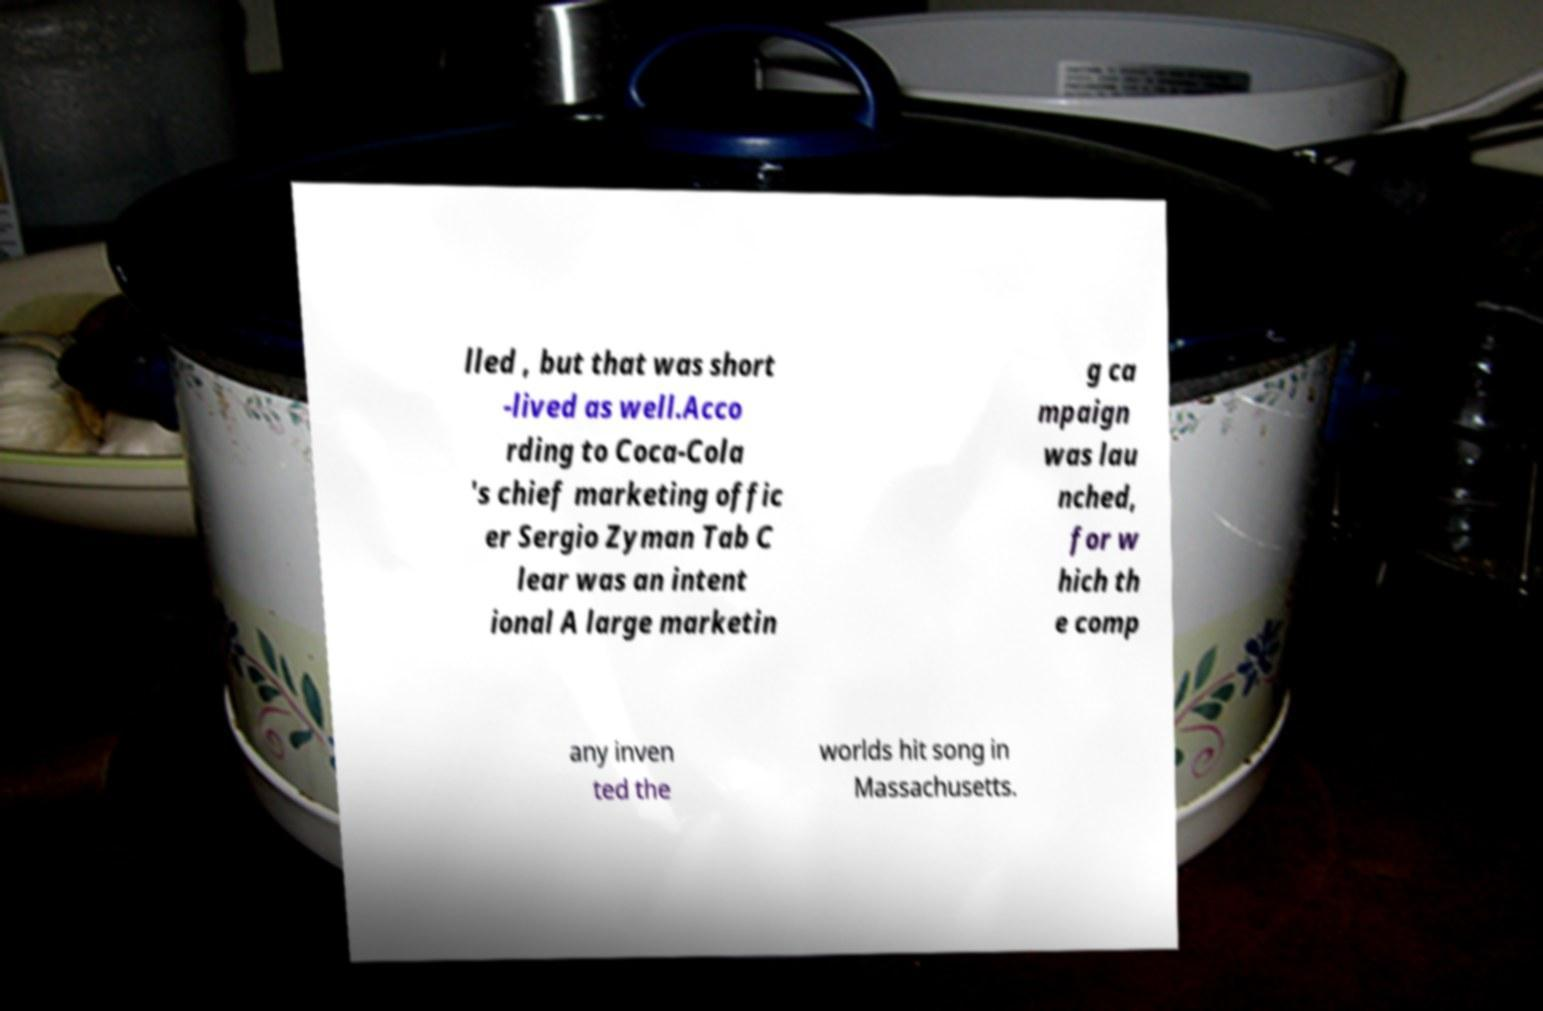Can you read and provide the text displayed in the image?This photo seems to have some interesting text. Can you extract and type it out for me? lled , but that was short -lived as well.Acco rding to Coca-Cola 's chief marketing offic er Sergio Zyman Tab C lear was an intent ional A large marketin g ca mpaign was lau nched, for w hich th e comp any inven ted the worlds hit song in Massachusetts. 